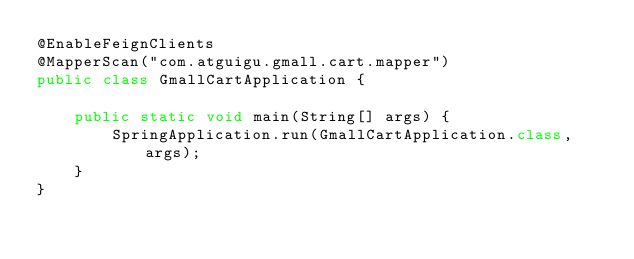<code> <loc_0><loc_0><loc_500><loc_500><_Java_>@EnableFeignClients
@MapperScan("com.atguigu.gmall.cart.mapper")
public class GmallCartApplication {

    public static void main(String[] args) {
        SpringApplication.run(GmallCartApplication.class, args);
    }
}
</code> 